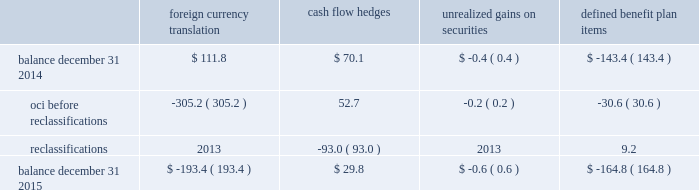Zimmer biomet holdings , inc .
2015 form 10-k annual report notes to consolidated financial statements ( continued ) interest to the date of redemption .
In addition , the merger notes and the 3.375% ( 3.375 % ) senior notes due 2021 may be redeemed at our option without any make-whole premium at specified dates ranging from one month to six months in advance of the scheduled maturity date .
Between the closing date and june 30 , 2015 , we repaid the biomet senior notes we assumed in the merger .
The fair value of the principal amount plus interest was $ 2798.6 million .
These senior notes required us to pay a call premium in excess of the fair value of the notes when they were repaid .
As a result , we recognized $ 22.0 million in non-operating other expense related to this call premium .
The estimated fair value of our senior notes as of december 31 , 2015 , based on quoted prices for the specific securities from transactions in over-the-counter markets ( level 2 ) , was $ 8837.5 million .
The estimated fair value of the japan term loan as of december 31 , 2015 , based upon publicly available market yield curves and the terms of the debt ( level 2 ) , was $ 96.4 million .
The carrying value of the u.s .
Term loan approximates fair value as it bears interest at short-term variable market rates .
We have entered into interest rate swap agreements which we designated as fair value hedges of underlying fixed- rate obligations on our senior notes due 2019 and 2021 .
See note 14 for additional information regarding the interest rate swap agreements .
We also have available uncommitted credit facilities totaling $ 35.8 million .
At december 31 , 2015 and 2014 , the weighted average interest rate for our long-term borrowings was 2.9 percent and 3.5 percent , respectively .
We paid $ 207.1 million , $ 67.5 million and $ 68.1 million in interest during 2015 , 2014 and 2013 , respectively .
13 .
Accumulated other comprehensive ( loss ) income oci refers to certain gains and losses that under gaap are included in comprehensive income but are excluded from net earnings as these amounts are initially recorded as an adjustment to stockholders 2019 equity .
Amounts in oci may be reclassified to net earnings upon the occurrence of certain events .
Our oci is comprised of foreign currency translation adjustments , unrealized gains and losses on cash flow hedges , unrealized gains and losses on available-for-sale securities , and amortization of prior service costs and unrecognized gains and losses in actuarial assumptions on our defined benefit plans .
Foreign currency translation adjustments are reclassified to net earnings upon sale or upon a complete or substantially complete liquidation of an investment in a foreign entity .
Unrealized gains and losses on cash flow hedges are reclassified to net earnings when the hedged item affects net earnings .
Unrealized gains and losses on available-for-sale securities are reclassified to net earnings if we sell the security before maturity or if the unrealized loss is considered to be other-than-temporary .
Amounts related to defined benefit plans that are in oci are reclassified over the service periods of employees in the plan .
The reclassification amounts are allocated to all employees in the plans and , therefore , the reclassified amounts may become part of inventory to the extent they are considered direct labor costs .
See note 15 for more information on our defined benefit plans .
The table shows the changes in the components of oci , net of tax ( in millions ) : foreign currency translation hedges unrealized gains on securities defined benefit .

What percent did cash flow from hedges reduce after reclassification? 
Rationale: asked for reduction so the percent is positive
Computations: (93.0 / (70.1 + 52.7))
Answer: 0.75733. 